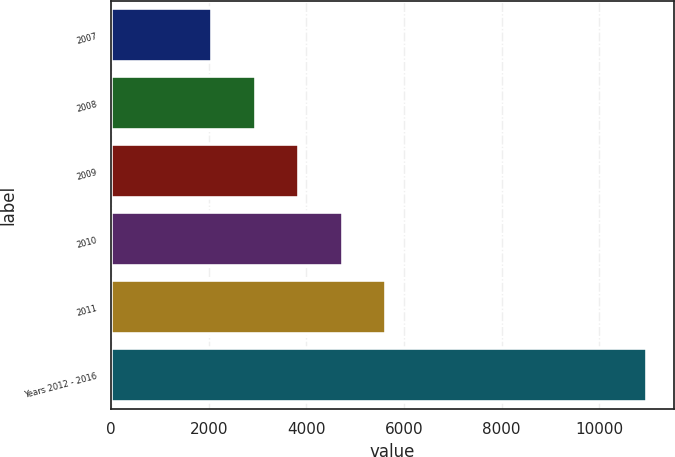Convert chart to OTSL. <chart><loc_0><loc_0><loc_500><loc_500><bar_chart><fcel>2007<fcel>2008<fcel>2009<fcel>2010<fcel>2011<fcel>Years 2012 - 2016<nl><fcel>2074<fcel>2964.5<fcel>3855<fcel>4745.5<fcel>5636<fcel>10979<nl></chart> 